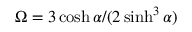<formula> <loc_0><loc_0><loc_500><loc_500>\Omega = { 3 \cosh \alpha } / { ( 2 \sinh ^ { 3 } \alpha ) }</formula> 